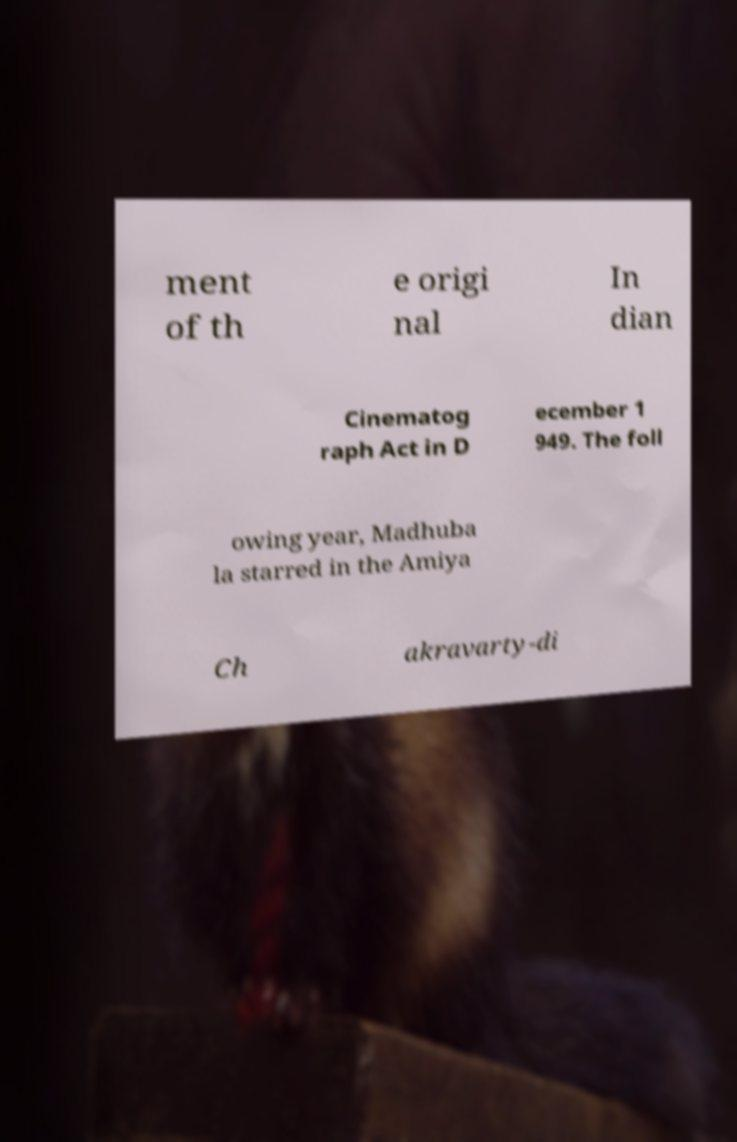There's text embedded in this image that I need extracted. Can you transcribe it verbatim? ment of th e origi nal In dian Cinematog raph Act in D ecember 1 949. The foll owing year, Madhuba la starred in the Amiya Ch akravarty-di 